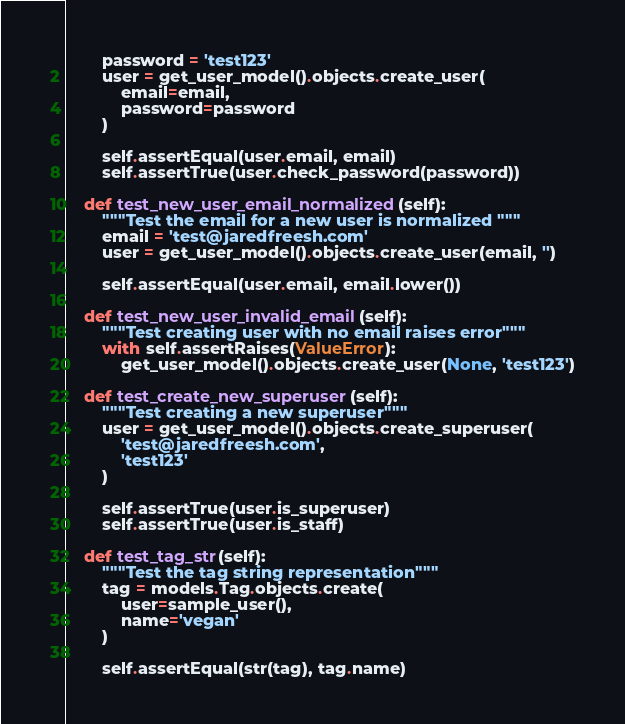Convert code to text. <code><loc_0><loc_0><loc_500><loc_500><_Python_>        password = 'test123'
        user = get_user_model().objects.create_user(
            email=email,
            password=password
        )

        self.assertEqual(user.email, email)
        self.assertTrue(user.check_password(password))

    def test_new_user_email_normalized(self):
        """Test the email for a new user is normalized """
        email = 'test@jaredfreesh.com'
        user = get_user_model().objects.create_user(email, '')

        self.assertEqual(user.email, email.lower())

    def test_new_user_invalid_email(self):
        """Test creating user with no email raises error"""
        with self.assertRaises(ValueError):
            get_user_model().objects.create_user(None, 'test123')

    def test_create_new_superuser(self):
        """Test creating a new superuser"""
        user = get_user_model().objects.create_superuser(
            'test@jaredfreesh.com',
            'test123'
        )

        self.assertTrue(user.is_superuser)
        self.assertTrue(user.is_staff)

    def test_tag_str(self):
        """Test the tag string representation"""
        tag = models.Tag.objects.create(
            user=sample_user(),
            name='vegan'
        )

        self.assertEqual(str(tag), tag.name)
</code> 